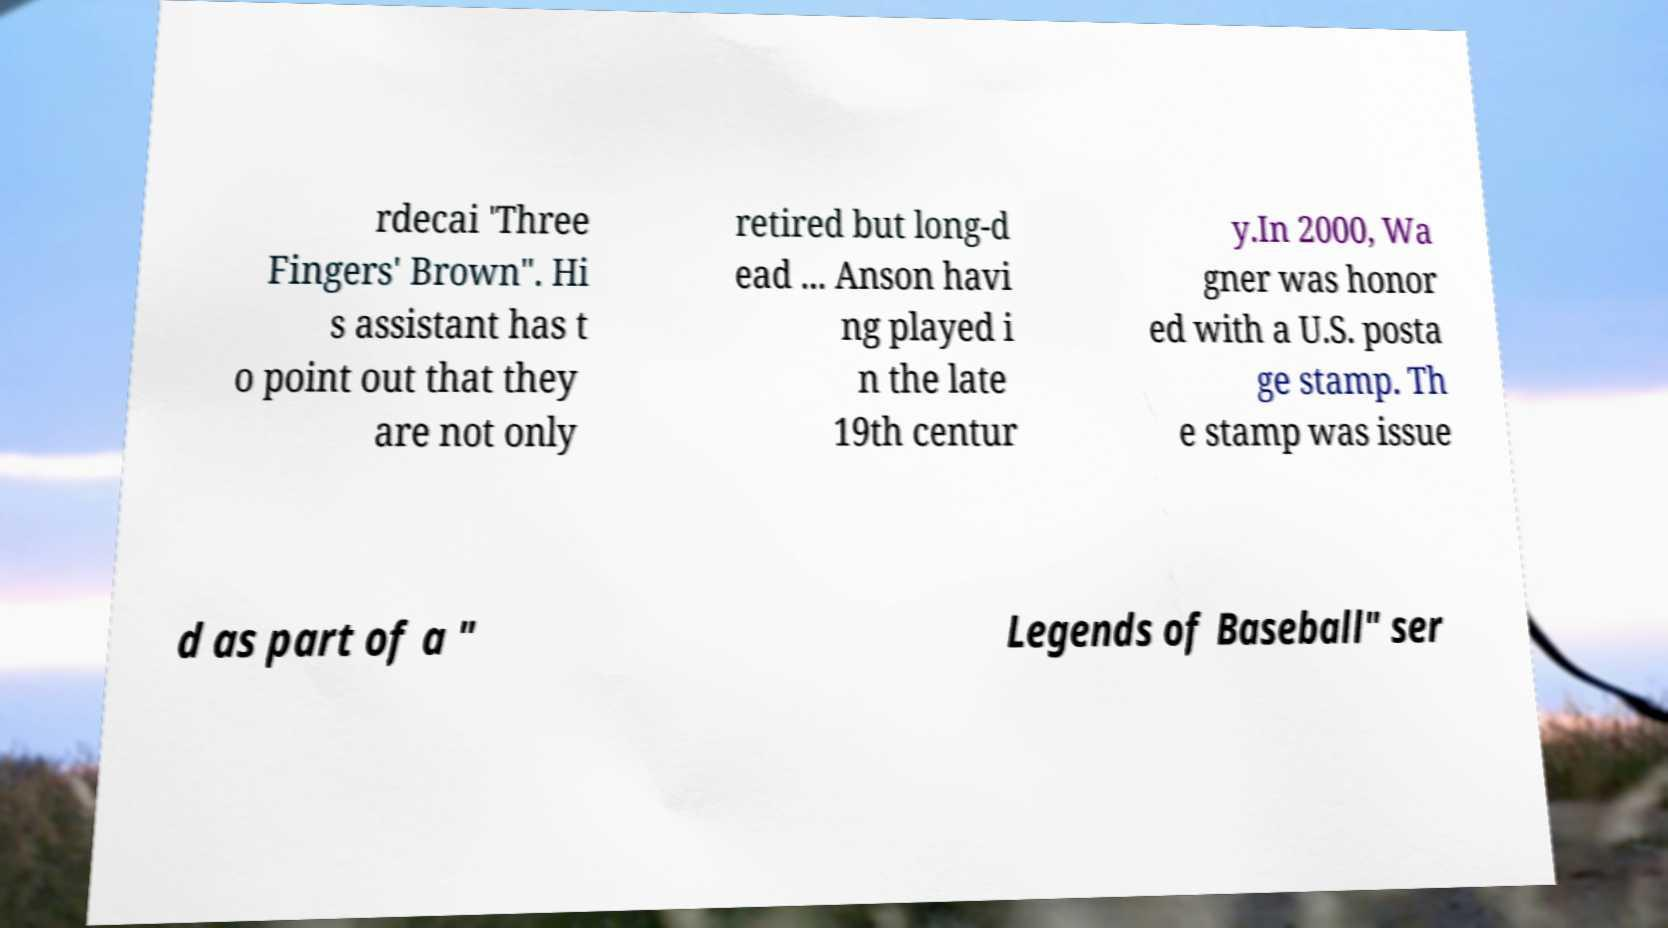For documentation purposes, I need the text within this image transcribed. Could you provide that? rdecai 'Three Fingers' Brown". Hi s assistant has t o point out that they are not only retired but long-d ead ... Anson havi ng played i n the late 19th centur y.In 2000, Wa gner was honor ed with a U.S. posta ge stamp. Th e stamp was issue d as part of a " Legends of Baseball" ser 